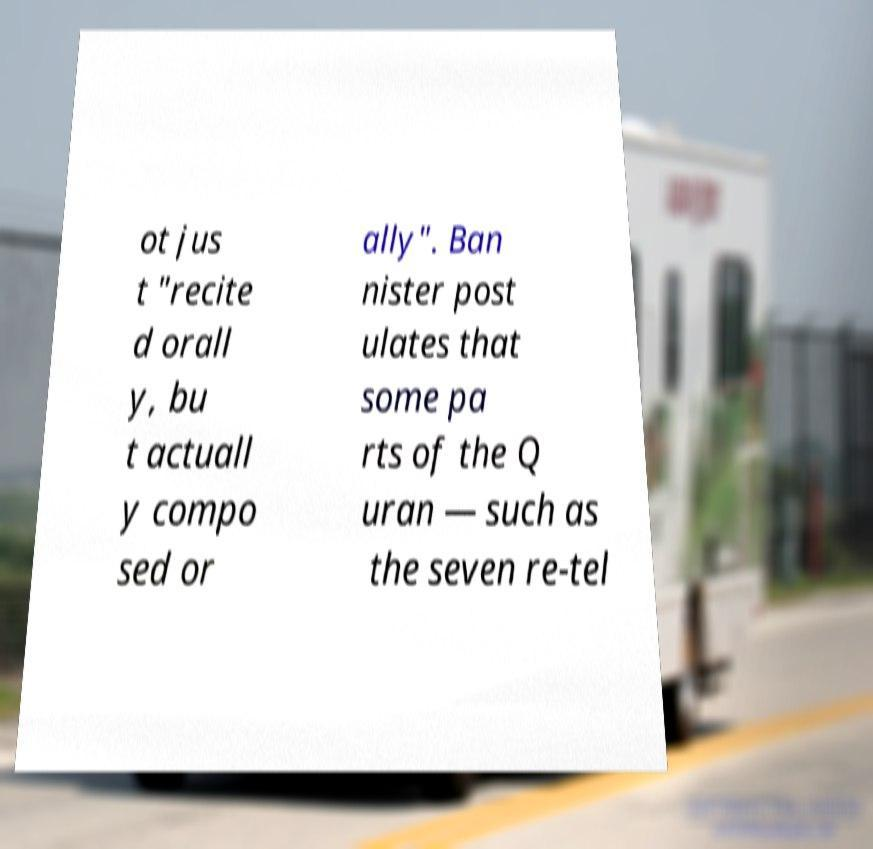Please identify and transcribe the text found in this image. ot jus t "recite d orall y, bu t actuall y compo sed or ally". Ban nister post ulates that some pa rts of the Q uran — such as the seven re-tel 